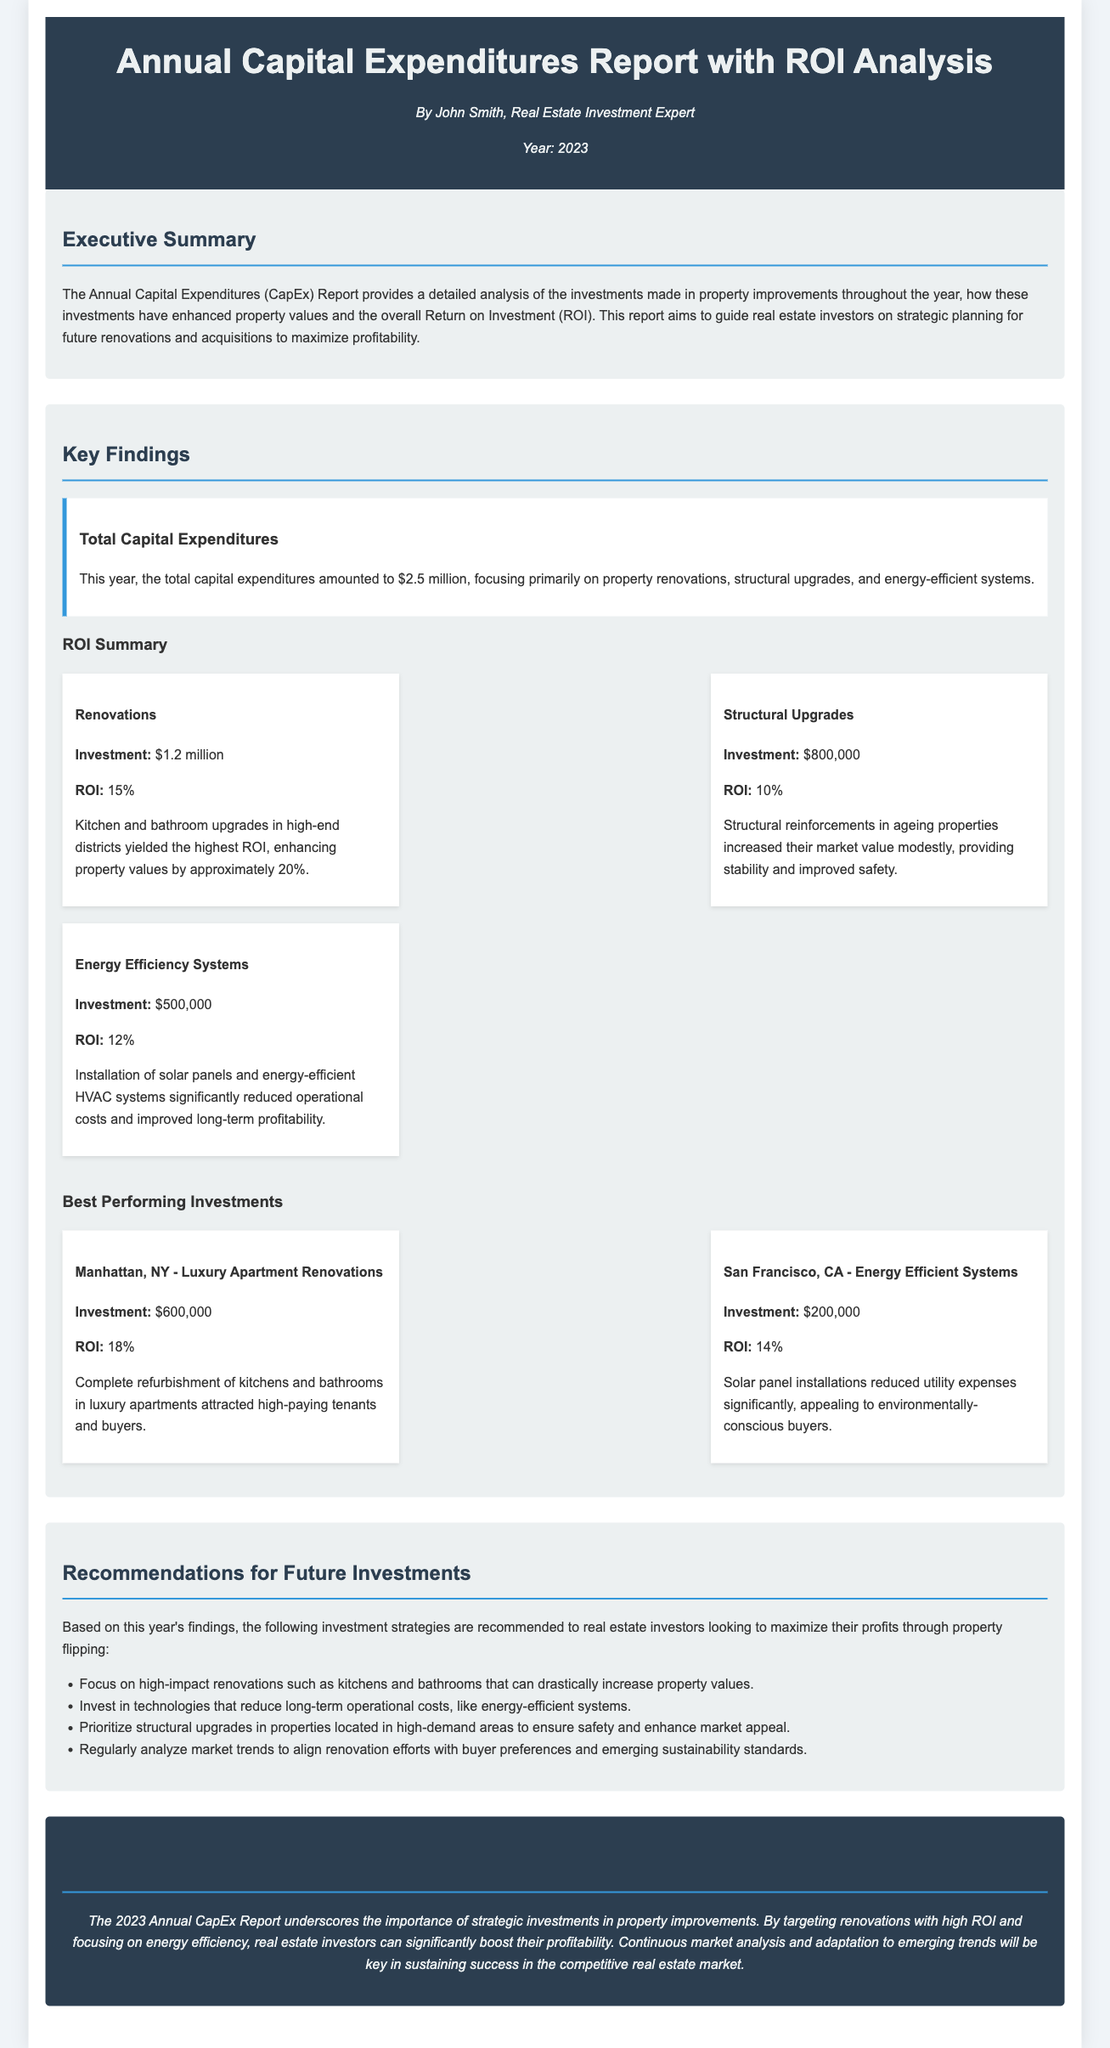what is the total capital expenditures? The total capital expenditures amount mentioned in the document is $2.5 million.
Answer: $2.5 million who is the author of the report? The author's name appears in the header of the document.
Answer: John Smith what is the ROI for renovations? The ROI for renovations is specifically stated in the ROI summary section.
Answer: 15% which property type had the highest ROI? The document indicates the type of property with the highest ROI in the best performing investments section.
Answer: Luxury Apartment Renovations what investment focused on energy efficiency? The document lists specific investments in energy-efficient systems in the ROI summary.
Answer: Solar panels and energy-efficient HVAC systems which area had the best-performing investment with an ROI of 18%? The location of the best-performing investment is provided in the best performing investments section.
Answer: Manhattan, NY what percentage did energy efficiency systems contribute to ROI? The ROI percentage for energy efficiency systems is listed in the ROI summary.
Answer: 12% what is one recommendation for future investments? Recommendations for future investments are provided in a list, and one can be referenced directly from the document.
Answer: Focus on high-impact renovations 